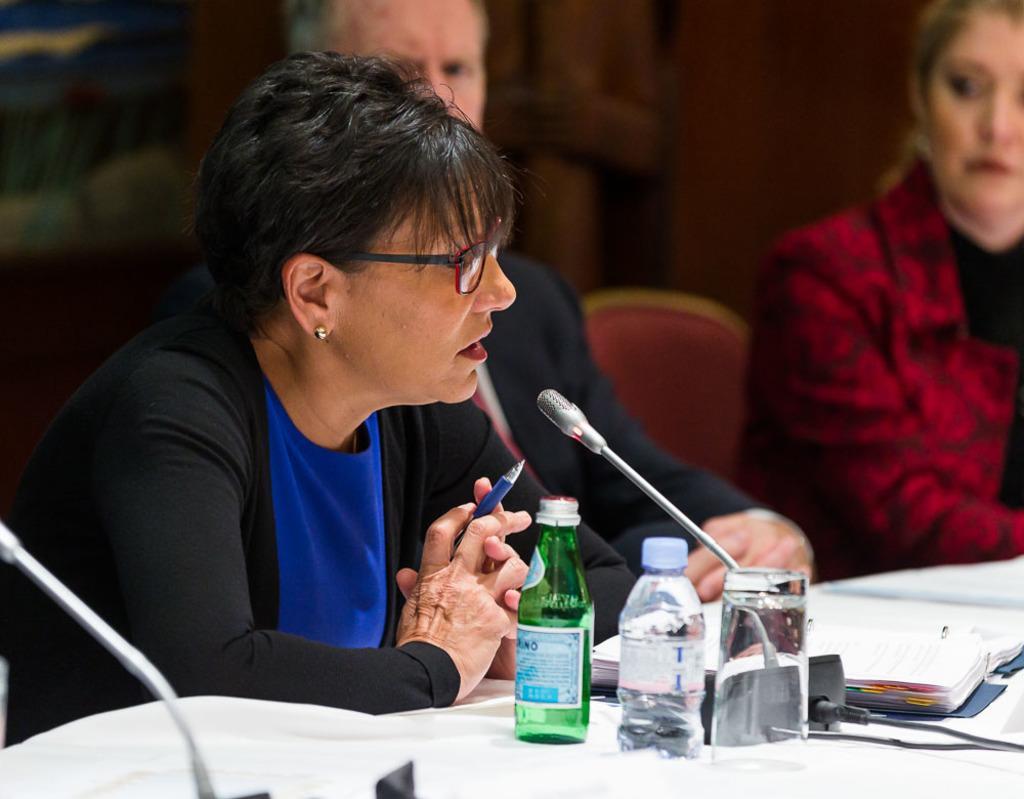Please provide a concise description of this image. In this picture there is a lady who is sitting st the left side of the image and there is a mic in front of the lady, there are other two people those who are sitting at the right side of the image and there is a table in front of them, were water bottles, glasses, and books are kept. 